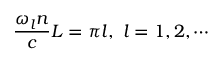<formula> <loc_0><loc_0><loc_500><loc_500>\frac { \omega _ { l } n } { c } L = \pi l , \ l = 1 , 2 , \cdots</formula> 